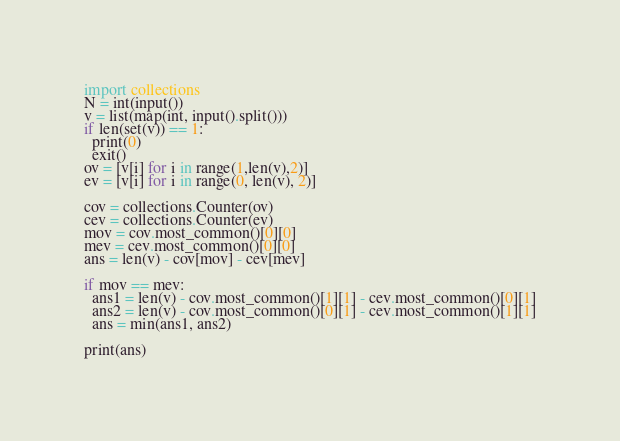Convert code to text. <code><loc_0><loc_0><loc_500><loc_500><_Python_>import collections
N = int(input())
v = list(map(int, input().split()))
if len(set(v)) == 1:
  print(0)
  exit()
ov = [v[i] for i in range(1,len(v),2)]
ev = [v[i] for i in range(0, len(v), 2)]

cov = collections.Counter(ov)
cev = collections.Counter(ev)
mov = cov.most_common()[0][0]
mev = cev.most_common()[0][0]
ans = len(v) - cov[mov] - cev[mev]

if mov == mev:
  ans1 = len(v) - cov.most_common()[1][1] - cev.most_common()[0][1]
  ans2 = len(v) - cov.most_common()[0][1] - cev.most_common()[1][1]
  ans = min(ans1, ans2)

print(ans)</code> 